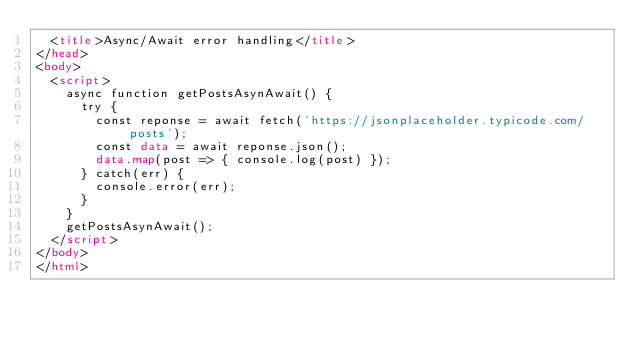Convert code to text. <code><loc_0><loc_0><loc_500><loc_500><_HTML_>  <title>Async/Await error handling</title>
</head>
<body>
  <script>   
    async function getPostsAsynAwait() {
      try {
        const reponse = await fetch('https://jsonplaceholder.typicode.com/posts');
        const data = await reponse.json();
        data.map(post => { console.log(post) });
      } catch(err) {
        console.error(err);
      }
    }
    getPostsAsynAwait();
  </script>
</body>
</html></code> 